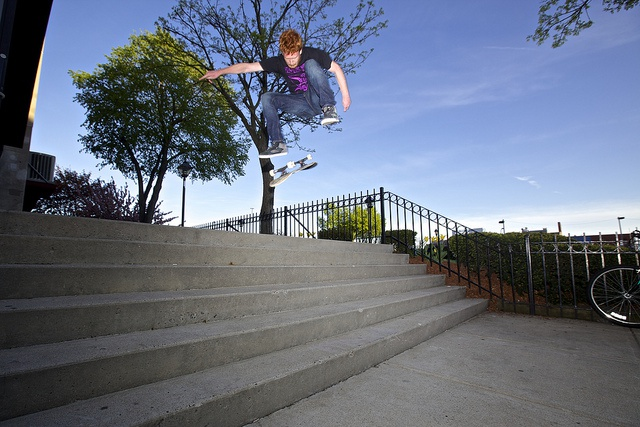Describe the objects in this image and their specific colors. I can see people in black, gray, and navy tones, bicycle in black, gray, white, and darkgray tones, and skateboard in black, white, darkgray, gray, and lightblue tones in this image. 